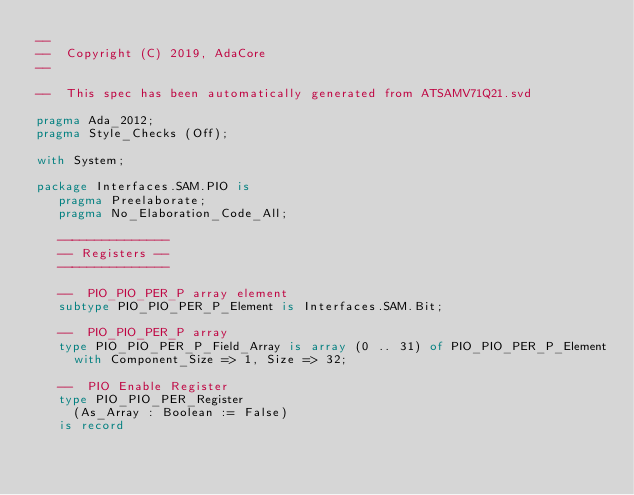<code> <loc_0><loc_0><loc_500><loc_500><_Ada_>--
--  Copyright (C) 2019, AdaCore
--

--  This spec has been automatically generated from ATSAMV71Q21.svd

pragma Ada_2012;
pragma Style_Checks (Off);

with System;

package Interfaces.SAM.PIO is
   pragma Preelaborate;
   pragma No_Elaboration_Code_All;

   ---------------
   -- Registers --
   ---------------

   --  PIO_PIO_PER_P array element
   subtype PIO_PIO_PER_P_Element is Interfaces.SAM.Bit;

   --  PIO_PIO_PER_P array
   type PIO_PIO_PER_P_Field_Array is array (0 .. 31) of PIO_PIO_PER_P_Element
     with Component_Size => 1, Size => 32;

   --  PIO Enable Register
   type PIO_PIO_PER_Register
     (As_Array : Boolean := False)
   is record</code> 